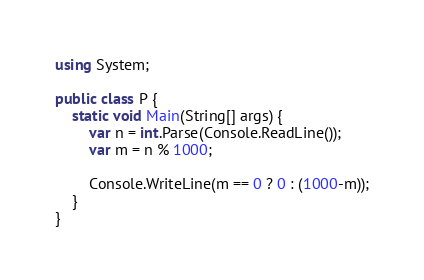<code> <loc_0><loc_0><loc_500><loc_500><_C#_>using System;

public class P {
	static void Main(String[] args) {
    	var n = int.Parse(Console.ReadLine());
        var m = n % 1000;

        Console.WriteLine(m == 0 ? 0 : (1000-m));
    } 
}</code> 